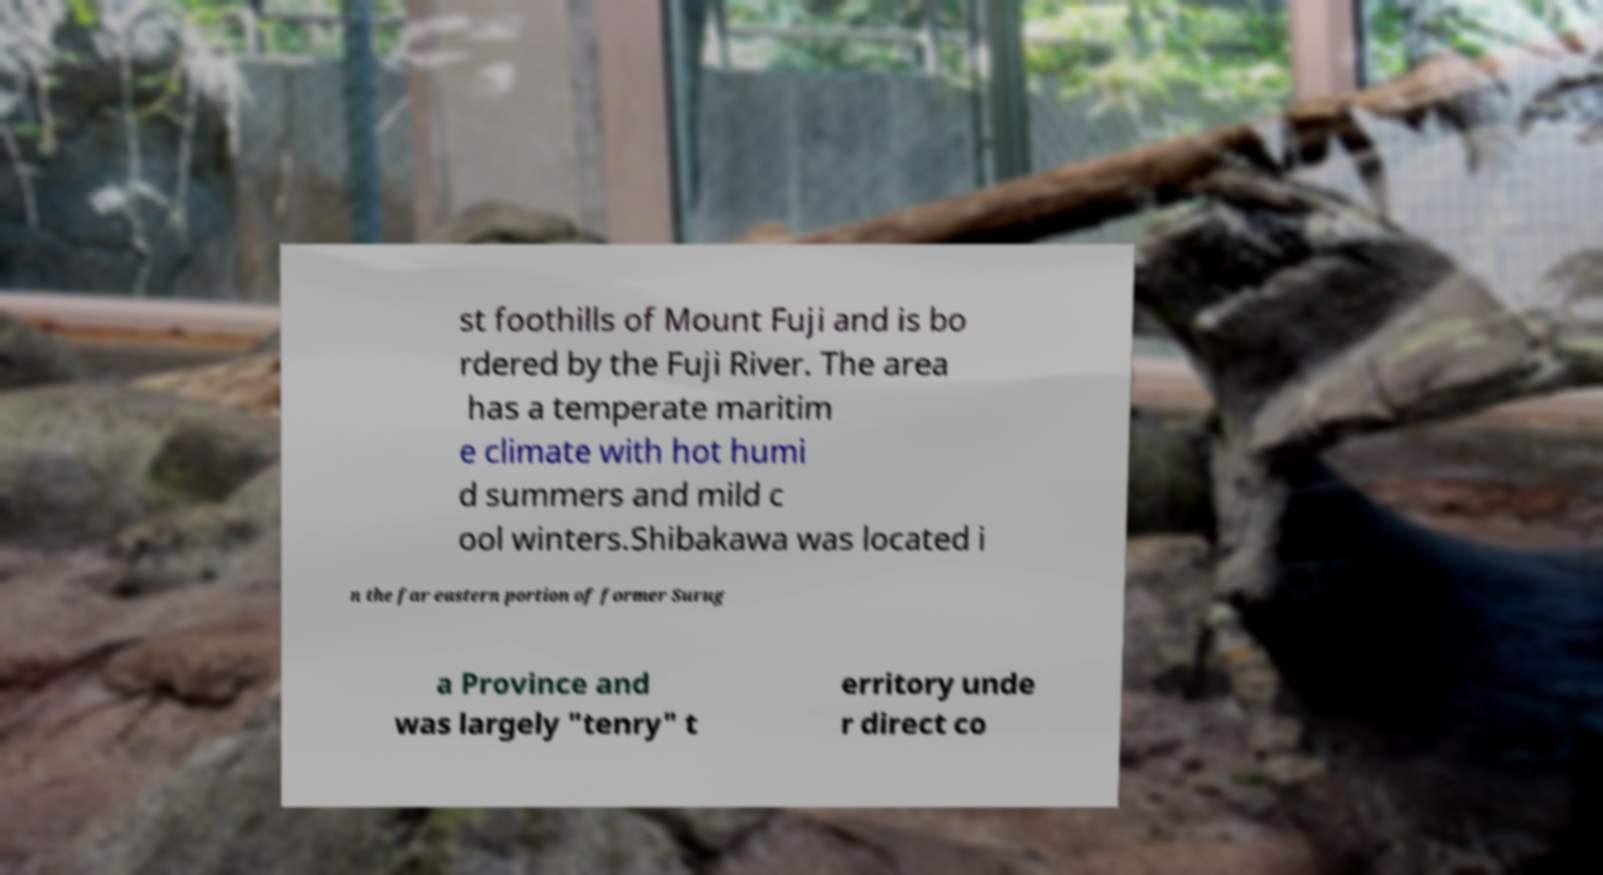What messages or text are displayed in this image? I need them in a readable, typed format. st foothills of Mount Fuji and is bo rdered by the Fuji River. The area has a temperate maritim e climate with hot humi d summers and mild c ool winters.Shibakawa was located i n the far eastern portion of former Surug a Province and was largely "tenry" t erritory unde r direct co 